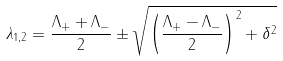Convert formula to latex. <formula><loc_0><loc_0><loc_500><loc_500>\lambda _ { 1 , 2 } = \frac { \Lambda _ { + } + \Lambda _ { - } } { 2 } \pm \sqrt { \left ( \frac { \Lambda _ { + } - \Lambda _ { - } } { 2 } \right ) ^ { 2 } + \delta ^ { 2 } }</formula> 